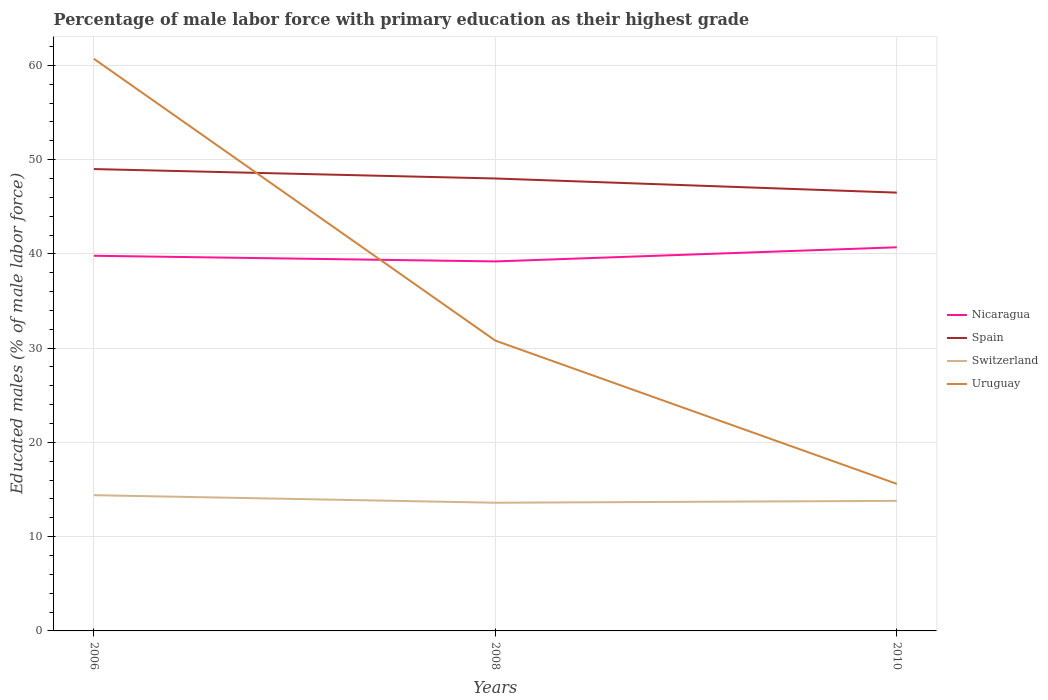Across all years, what is the maximum percentage of male labor force with primary education in Nicaragua?
Offer a terse response. 39.2. What is the difference between the highest and the second highest percentage of male labor force with primary education in Switzerland?
Your answer should be very brief. 0.8. What is the difference between the highest and the lowest percentage of male labor force with primary education in Spain?
Provide a short and direct response. 2. Is the percentage of male labor force with primary education in Switzerland strictly greater than the percentage of male labor force with primary education in Spain over the years?
Your response must be concise. Yes. Does the graph contain grids?
Provide a succinct answer. Yes. Where does the legend appear in the graph?
Provide a short and direct response. Center right. How are the legend labels stacked?
Ensure brevity in your answer.  Vertical. What is the title of the graph?
Offer a very short reply. Percentage of male labor force with primary education as their highest grade. Does "Kyrgyz Republic" appear as one of the legend labels in the graph?
Offer a terse response. No. What is the label or title of the Y-axis?
Offer a very short reply. Educated males (% of male labor force). What is the Educated males (% of male labor force) in Nicaragua in 2006?
Offer a very short reply. 39.8. What is the Educated males (% of male labor force) of Spain in 2006?
Keep it short and to the point. 49. What is the Educated males (% of male labor force) in Switzerland in 2006?
Provide a succinct answer. 14.4. What is the Educated males (% of male labor force) in Uruguay in 2006?
Make the answer very short. 60.7. What is the Educated males (% of male labor force) in Nicaragua in 2008?
Offer a very short reply. 39.2. What is the Educated males (% of male labor force) in Switzerland in 2008?
Provide a succinct answer. 13.6. What is the Educated males (% of male labor force) of Uruguay in 2008?
Give a very brief answer. 30.8. What is the Educated males (% of male labor force) of Nicaragua in 2010?
Ensure brevity in your answer.  40.7. What is the Educated males (% of male labor force) of Spain in 2010?
Offer a very short reply. 46.5. What is the Educated males (% of male labor force) in Switzerland in 2010?
Make the answer very short. 13.8. What is the Educated males (% of male labor force) in Uruguay in 2010?
Ensure brevity in your answer.  15.6. Across all years, what is the maximum Educated males (% of male labor force) of Nicaragua?
Keep it short and to the point. 40.7. Across all years, what is the maximum Educated males (% of male labor force) of Switzerland?
Ensure brevity in your answer.  14.4. Across all years, what is the maximum Educated males (% of male labor force) in Uruguay?
Give a very brief answer. 60.7. Across all years, what is the minimum Educated males (% of male labor force) in Nicaragua?
Your answer should be very brief. 39.2. Across all years, what is the minimum Educated males (% of male labor force) in Spain?
Your answer should be compact. 46.5. Across all years, what is the minimum Educated males (% of male labor force) in Switzerland?
Ensure brevity in your answer.  13.6. Across all years, what is the minimum Educated males (% of male labor force) in Uruguay?
Your answer should be very brief. 15.6. What is the total Educated males (% of male labor force) in Nicaragua in the graph?
Your answer should be very brief. 119.7. What is the total Educated males (% of male labor force) in Spain in the graph?
Keep it short and to the point. 143.5. What is the total Educated males (% of male labor force) of Switzerland in the graph?
Your response must be concise. 41.8. What is the total Educated males (% of male labor force) in Uruguay in the graph?
Your response must be concise. 107.1. What is the difference between the Educated males (% of male labor force) of Spain in 2006 and that in 2008?
Offer a terse response. 1. What is the difference between the Educated males (% of male labor force) of Uruguay in 2006 and that in 2008?
Ensure brevity in your answer.  29.9. What is the difference between the Educated males (% of male labor force) in Nicaragua in 2006 and that in 2010?
Offer a very short reply. -0.9. What is the difference between the Educated males (% of male labor force) of Spain in 2006 and that in 2010?
Provide a succinct answer. 2.5. What is the difference between the Educated males (% of male labor force) in Uruguay in 2006 and that in 2010?
Your answer should be compact. 45.1. What is the difference between the Educated males (% of male labor force) of Switzerland in 2008 and that in 2010?
Provide a succinct answer. -0.2. What is the difference between the Educated males (% of male labor force) of Uruguay in 2008 and that in 2010?
Make the answer very short. 15.2. What is the difference between the Educated males (% of male labor force) in Nicaragua in 2006 and the Educated males (% of male labor force) in Spain in 2008?
Offer a terse response. -8.2. What is the difference between the Educated males (% of male labor force) in Nicaragua in 2006 and the Educated males (% of male labor force) in Switzerland in 2008?
Your answer should be compact. 26.2. What is the difference between the Educated males (% of male labor force) in Spain in 2006 and the Educated males (% of male labor force) in Switzerland in 2008?
Your answer should be compact. 35.4. What is the difference between the Educated males (% of male labor force) of Spain in 2006 and the Educated males (% of male labor force) of Uruguay in 2008?
Provide a succinct answer. 18.2. What is the difference between the Educated males (% of male labor force) in Switzerland in 2006 and the Educated males (% of male labor force) in Uruguay in 2008?
Provide a succinct answer. -16.4. What is the difference between the Educated males (% of male labor force) of Nicaragua in 2006 and the Educated males (% of male labor force) of Spain in 2010?
Ensure brevity in your answer.  -6.7. What is the difference between the Educated males (% of male labor force) of Nicaragua in 2006 and the Educated males (% of male labor force) of Switzerland in 2010?
Provide a short and direct response. 26. What is the difference between the Educated males (% of male labor force) in Nicaragua in 2006 and the Educated males (% of male labor force) in Uruguay in 2010?
Your answer should be compact. 24.2. What is the difference between the Educated males (% of male labor force) of Spain in 2006 and the Educated males (% of male labor force) of Switzerland in 2010?
Ensure brevity in your answer.  35.2. What is the difference between the Educated males (% of male labor force) in Spain in 2006 and the Educated males (% of male labor force) in Uruguay in 2010?
Make the answer very short. 33.4. What is the difference between the Educated males (% of male labor force) in Nicaragua in 2008 and the Educated males (% of male labor force) in Switzerland in 2010?
Offer a terse response. 25.4. What is the difference between the Educated males (% of male labor force) of Nicaragua in 2008 and the Educated males (% of male labor force) of Uruguay in 2010?
Your response must be concise. 23.6. What is the difference between the Educated males (% of male labor force) in Spain in 2008 and the Educated males (% of male labor force) in Switzerland in 2010?
Give a very brief answer. 34.2. What is the difference between the Educated males (% of male labor force) in Spain in 2008 and the Educated males (% of male labor force) in Uruguay in 2010?
Ensure brevity in your answer.  32.4. What is the average Educated males (% of male labor force) in Nicaragua per year?
Provide a succinct answer. 39.9. What is the average Educated males (% of male labor force) of Spain per year?
Your response must be concise. 47.83. What is the average Educated males (% of male labor force) in Switzerland per year?
Provide a short and direct response. 13.93. What is the average Educated males (% of male labor force) of Uruguay per year?
Make the answer very short. 35.7. In the year 2006, what is the difference between the Educated males (% of male labor force) in Nicaragua and Educated males (% of male labor force) in Spain?
Your answer should be compact. -9.2. In the year 2006, what is the difference between the Educated males (% of male labor force) of Nicaragua and Educated males (% of male labor force) of Switzerland?
Provide a short and direct response. 25.4. In the year 2006, what is the difference between the Educated males (% of male labor force) in Nicaragua and Educated males (% of male labor force) in Uruguay?
Offer a very short reply. -20.9. In the year 2006, what is the difference between the Educated males (% of male labor force) in Spain and Educated males (% of male labor force) in Switzerland?
Make the answer very short. 34.6. In the year 2006, what is the difference between the Educated males (% of male labor force) of Spain and Educated males (% of male labor force) of Uruguay?
Give a very brief answer. -11.7. In the year 2006, what is the difference between the Educated males (% of male labor force) of Switzerland and Educated males (% of male labor force) of Uruguay?
Offer a very short reply. -46.3. In the year 2008, what is the difference between the Educated males (% of male labor force) in Nicaragua and Educated males (% of male labor force) in Switzerland?
Your answer should be very brief. 25.6. In the year 2008, what is the difference between the Educated males (% of male labor force) in Spain and Educated males (% of male labor force) in Switzerland?
Your response must be concise. 34.4. In the year 2008, what is the difference between the Educated males (% of male labor force) of Switzerland and Educated males (% of male labor force) of Uruguay?
Give a very brief answer. -17.2. In the year 2010, what is the difference between the Educated males (% of male labor force) in Nicaragua and Educated males (% of male labor force) in Spain?
Your answer should be compact. -5.8. In the year 2010, what is the difference between the Educated males (% of male labor force) of Nicaragua and Educated males (% of male labor force) of Switzerland?
Your answer should be very brief. 26.9. In the year 2010, what is the difference between the Educated males (% of male labor force) in Nicaragua and Educated males (% of male labor force) in Uruguay?
Give a very brief answer. 25.1. In the year 2010, what is the difference between the Educated males (% of male labor force) in Spain and Educated males (% of male labor force) in Switzerland?
Ensure brevity in your answer.  32.7. In the year 2010, what is the difference between the Educated males (% of male labor force) of Spain and Educated males (% of male labor force) of Uruguay?
Your answer should be very brief. 30.9. In the year 2010, what is the difference between the Educated males (% of male labor force) of Switzerland and Educated males (% of male labor force) of Uruguay?
Offer a very short reply. -1.8. What is the ratio of the Educated males (% of male labor force) in Nicaragua in 2006 to that in 2008?
Make the answer very short. 1.02. What is the ratio of the Educated males (% of male labor force) of Spain in 2006 to that in 2008?
Your response must be concise. 1.02. What is the ratio of the Educated males (% of male labor force) in Switzerland in 2006 to that in 2008?
Your answer should be very brief. 1.06. What is the ratio of the Educated males (% of male labor force) in Uruguay in 2006 to that in 2008?
Offer a very short reply. 1.97. What is the ratio of the Educated males (% of male labor force) of Nicaragua in 2006 to that in 2010?
Keep it short and to the point. 0.98. What is the ratio of the Educated males (% of male labor force) of Spain in 2006 to that in 2010?
Your response must be concise. 1.05. What is the ratio of the Educated males (% of male labor force) in Switzerland in 2006 to that in 2010?
Provide a succinct answer. 1.04. What is the ratio of the Educated males (% of male labor force) in Uruguay in 2006 to that in 2010?
Ensure brevity in your answer.  3.89. What is the ratio of the Educated males (% of male labor force) of Nicaragua in 2008 to that in 2010?
Offer a terse response. 0.96. What is the ratio of the Educated males (% of male labor force) of Spain in 2008 to that in 2010?
Your answer should be compact. 1.03. What is the ratio of the Educated males (% of male labor force) in Switzerland in 2008 to that in 2010?
Your response must be concise. 0.99. What is the ratio of the Educated males (% of male labor force) in Uruguay in 2008 to that in 2010?
Your response must be concise. 1.97. What is the difference between the highest and the second highest Educated males (% of male labor force) of Uruguay?
Provide a succinct answer. 29.9. What is the difference between the highest and the lowest Educated males (% of male labor force) in Switzerland?
Make the answer very short. 0.8. What is the difference between the highest and the lowest Educated males (% of male labor force) of Uruguay?
Provide a short and direct response. 45.1. 